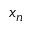Convert formula to latex. <formula><loc_0><loc_0><loc_500><loc_500>x _ { n }</formula> 